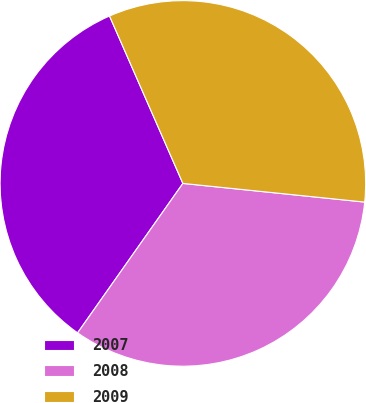Convert chart to OTSL. <chart><loc_0><loc_0><loc_500><loc_500><pie_chart><fcel>2007<fcel>2008<fcel>2009<nl><fcel>33.66%<fcel>33.14%<fcel>33.2%<nl></chart> 